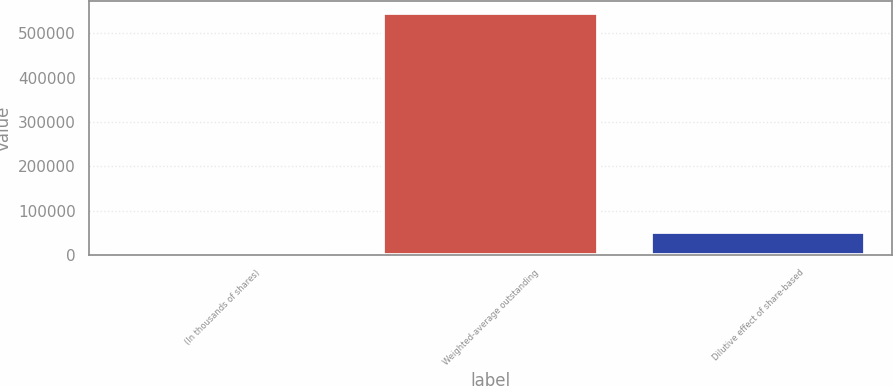Convert chart. <chart><loc_0><loc_0><loc_500><loc_500><bar_chart><fcel>(In thousands of shares)<fcel>Weighted-average outstanding<fcel>Dilutive effect of share-based<nl><fcel>2006<fcel>545596<fcel>51988.1<nl></chart> 